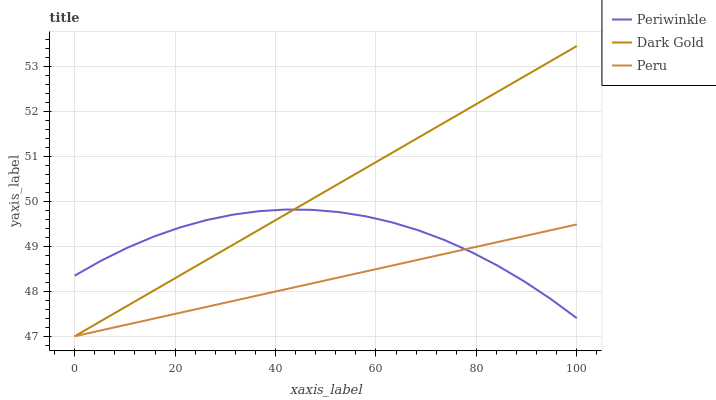Does Peru have the minimum area under the curve?
Answer yes or no. Yes. Does Dark Gold have the maximum area under the curve?
Answer yes or no. Yes. Does Dark Gold have the minimum area under the curve?
Answer yes or no. No. Does Peru have the maximum area under the curve?
Answer yes or no. No. Is Dark Gold the smoothest?
Answer yes or no. Yes. Is Periwinkle the roughest?
Answer yes or no. Yes. Is Peru the smoothest?
Answer yes or no. No. Is Peru the roughest?
Answer yes or no. No. Does Peru have the lowest value?
Answer yes or no. Yes. Does Dark Gold have the highest value?
Answer yes or no. Yes. Does Peru have the highest value?
Answer yes or no. No. Does Periwinkle intersect Peru?
Answer yes or no. Yes. Is Periwinkle less than Peru?
Answer yes or no. No. Is Periwinkle greater than Peru?
Answer yes or no. No. 